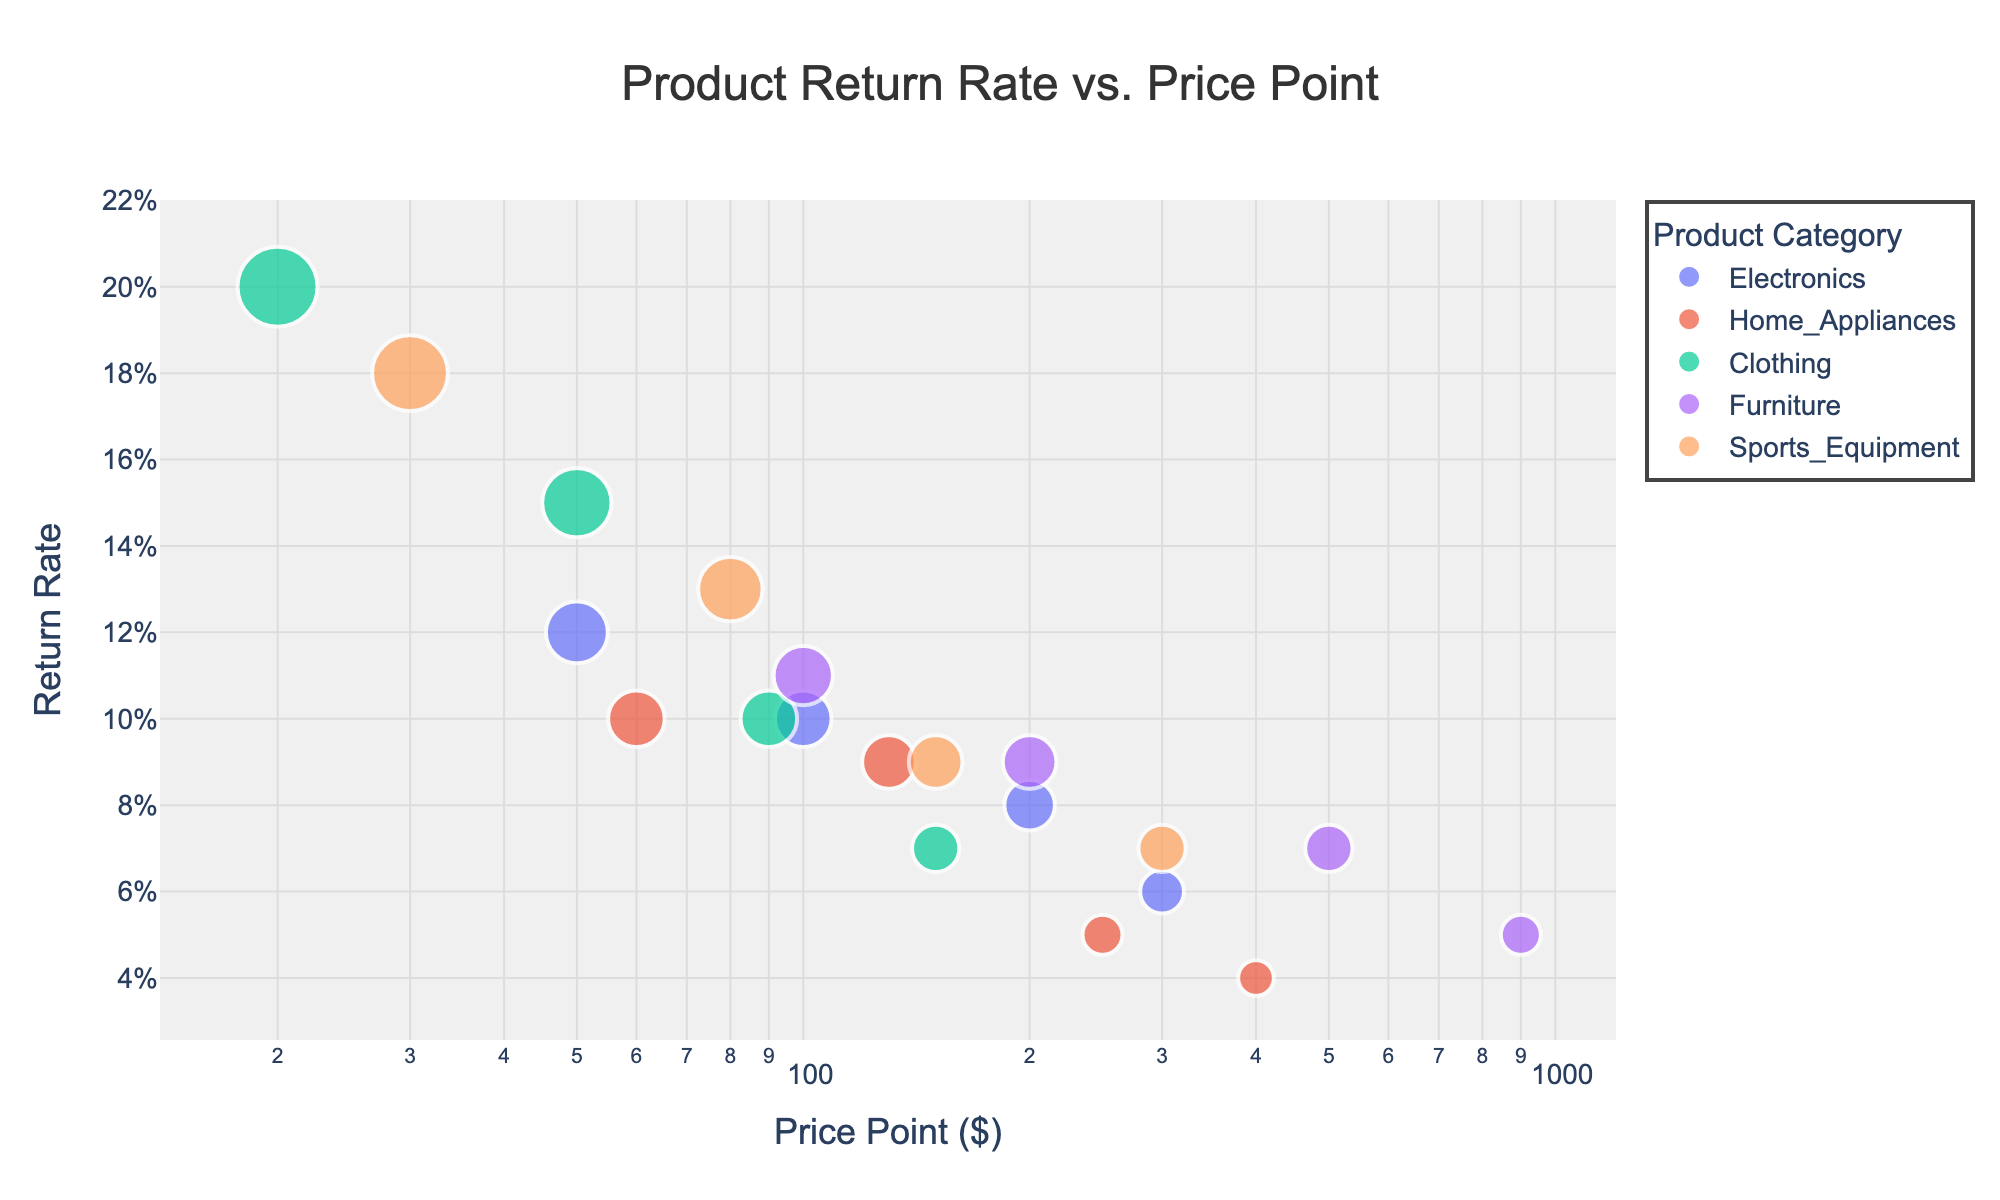What's the title of the figure? The title of a figure is typically displayed at the top and summarizes what the plot represents. In this case, the title is shown as "Product Return Rate vs. Price Point".
Answer: Product Return Rate vs. Price Point Which product category has the highest return rate at the lowest price point? To answer this, look at the lowest points on the x-axis (price point) for each category and see which one has the highest value on the y-axis (return rate). Clothing at $19.99 has a return rate of 0.20, the highest among all categories at their lowest price point.
Answer: Clothing What is the trend in return rate as price increases for Electronics? Locate the points for Electronics and observe the pattern from left to right (as the price increases). The return rate decreases from 0.12 at $49.99 to 0.06 at $299.99. Therefore, the trend shows a decreasing return rate with an increase in price.
Answer: Decreasing Which product category has the lowest return rate at the highest price point? Find the highest price points (rightmost points) for each category and compare their return rates. Home Appliances at $399.99 and Furniture at $899.99 both have a return rate of 0.04 and 0.05, respectively. The lowest is Home Appliances with a 0.04 return rate.
Answer: Home Appliances What is the average return rate for the Clothing category? Identify the return rates for Clothing (0.20, 0.15, 0.10, 0.07). Calculate the average by summing these rates and then dividing by the number of data points: (0.20 + 0.15 + 0.10 + 0.07) / 4 = 0.13.
Answer: 0.13 How does the return rate for Sports Equipment at $149.99 compare to Furniture at $199.99? Look for the return rate values for Sports Equipment at $149.99 (0.09) and Furniture at $199.99 (0.09). Both categories show the same return rate of 0.09 at these respective price points.
Answer: Equal Is there a product category where the return rate increases as the price point increases? Check each category's trend. All categories display a decreasing return rate as the price increases; none show an increasing return rate with higher prices.
Answer: No What is the price point range for Home Appliances? Find the lowest and highest price points on the x-axis that correspond to Home Appliances data points, which range from $59.99 to $399.99.
Answer: $59.99 - $399.99 Do higher price points generally correlate with lower return rates? Observe the overall trend for all categories on the scatter plot. The general trend shows that as the price point increases (moving right on the x-axis), the return rate tends to decrease (moving down on the y-axis), indicating a negative correlation.
Answer: Yes 